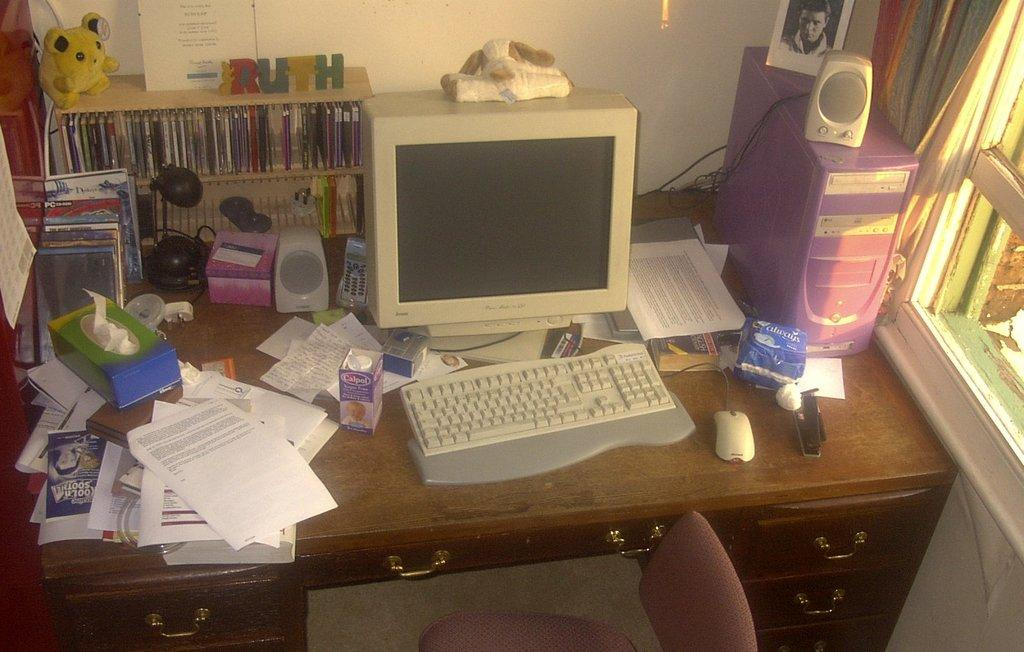Provide a one-sentence caption for the provided image. A computer desk filled with objects and a pack of feminine pads by Always beside the keyboard. 